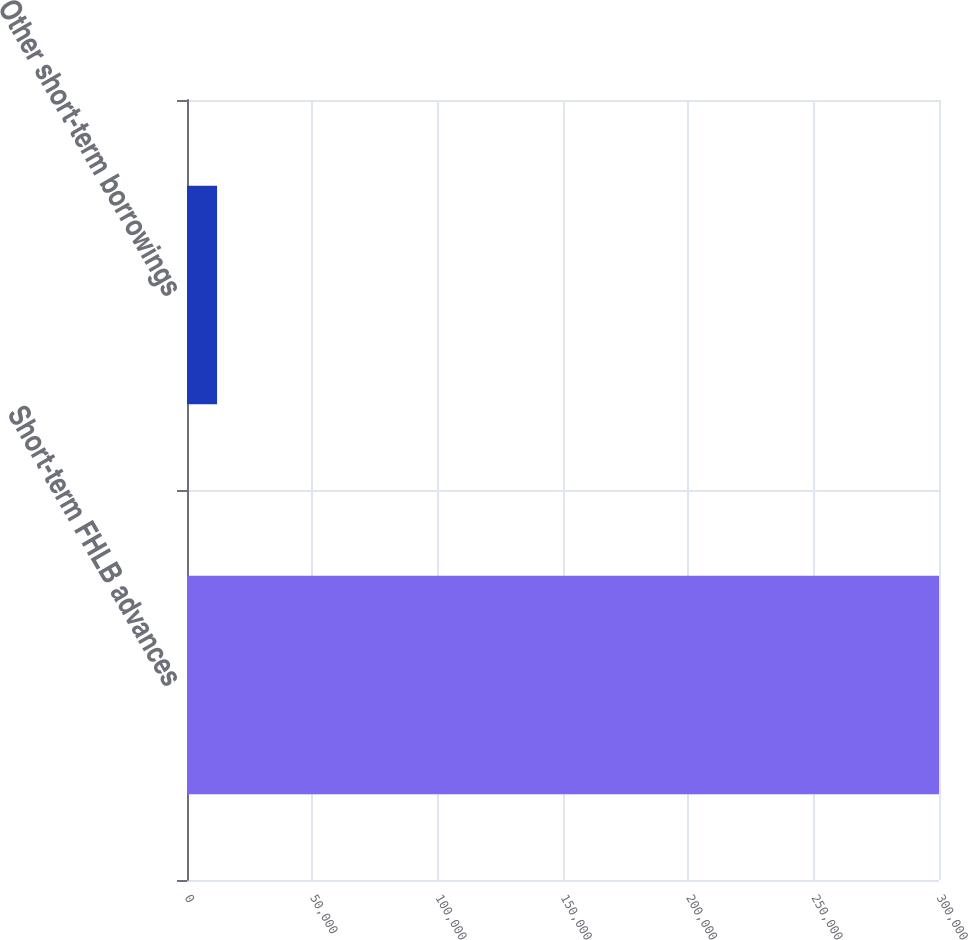<chart> <loc_0><loc_0><loc_500><loc_500><bar_chart><fcel>Short-term FHLB advances<fcel>Other short-term borrowings<nl><fcel>300000<fcel>11998<nl></chart> 